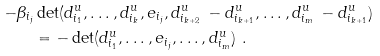Convert formula to latex. <formula><loc_0><loc_0><loc_500><loc_500>- \beta _ { i _ { j } } & \det ( d ^ { u } _ { i _ { 1 } } , \dots , d ^ { u } _ { i _ { k } } , e _ { i _ { j } } , d ^ { u } _ { i _ { k + 2 } } \, - d ^ { u } _ { i _ { k + 1 } } , \dots , d ^ { u } _ { i _ { m } } \, - d ^ { u } _ { i _ { k + 1 } } ) \\ & = - \det ( d ^ { u } _ { i _ { 1 } } , \dots , e _ { i _ { j } } , \dots , d ^ { u } _ { i _ { m } } ) \ .</formula> 